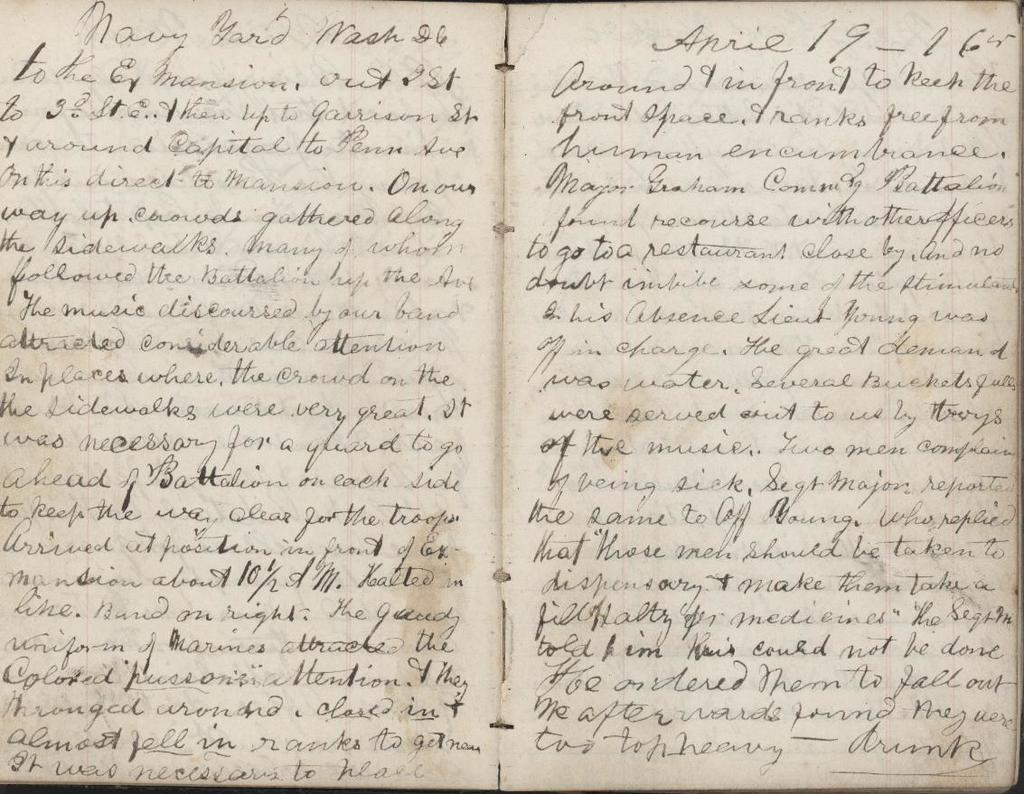Provide a one-sentence caption for the provided image. A handwritten book open with the date march 26 on the top right corner. 